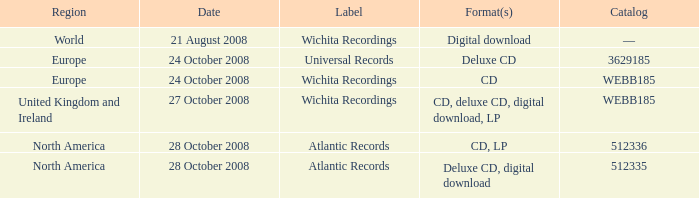Which inventory value contains a worldwide region? —. 